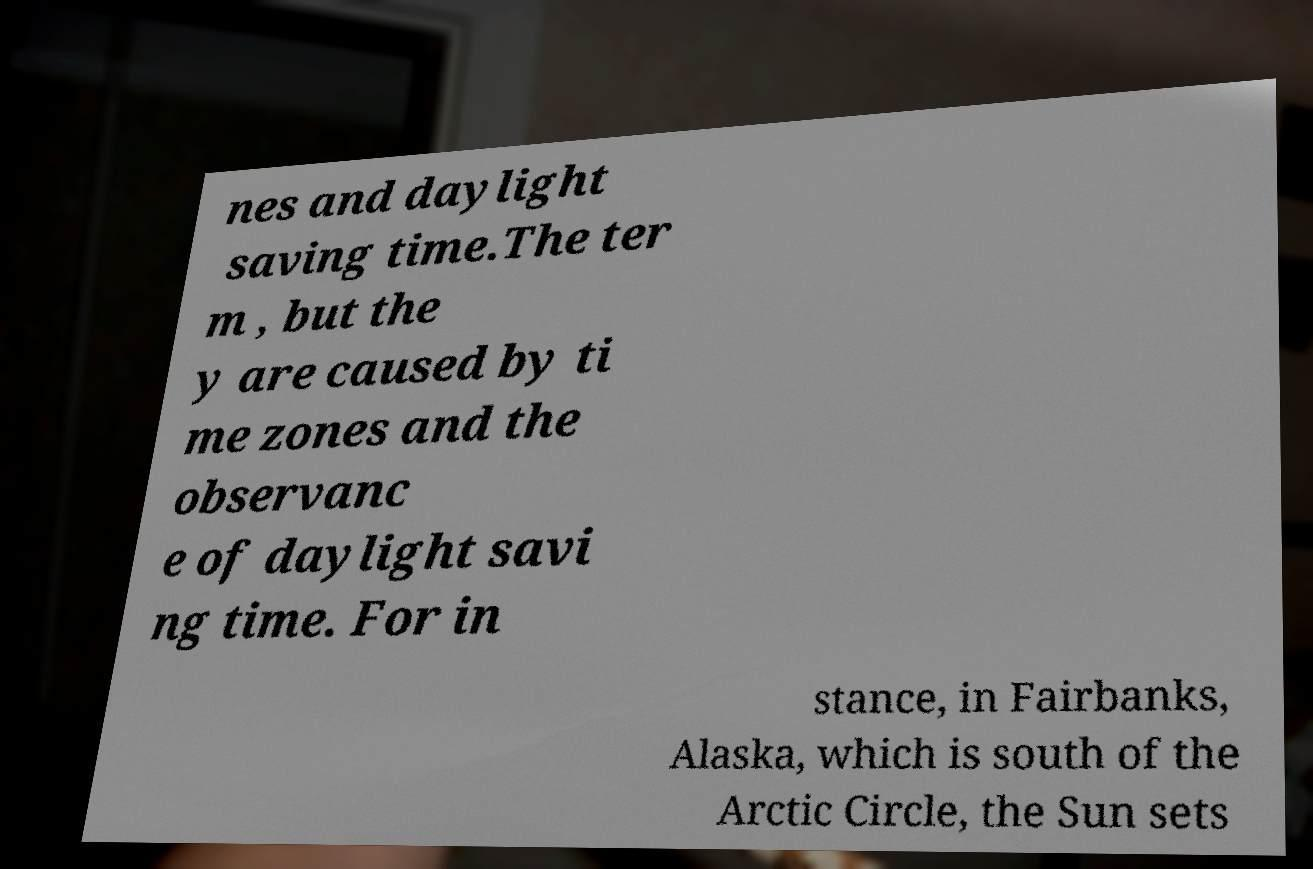I need the written content from this picture converted into text. Can you do that? nes and daylight saving time.The ter m , but the y are caused by ti me zones and the observanc e of daylight savi ng time. For in stance, in Fairbanks, Alaska, which is south of the Arctic Circle, the Sun sets 